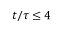Convert formula to latex. <formula><loc_0><loc_0><loc_500><loc_500>t / \tau \leq 4</formula> 